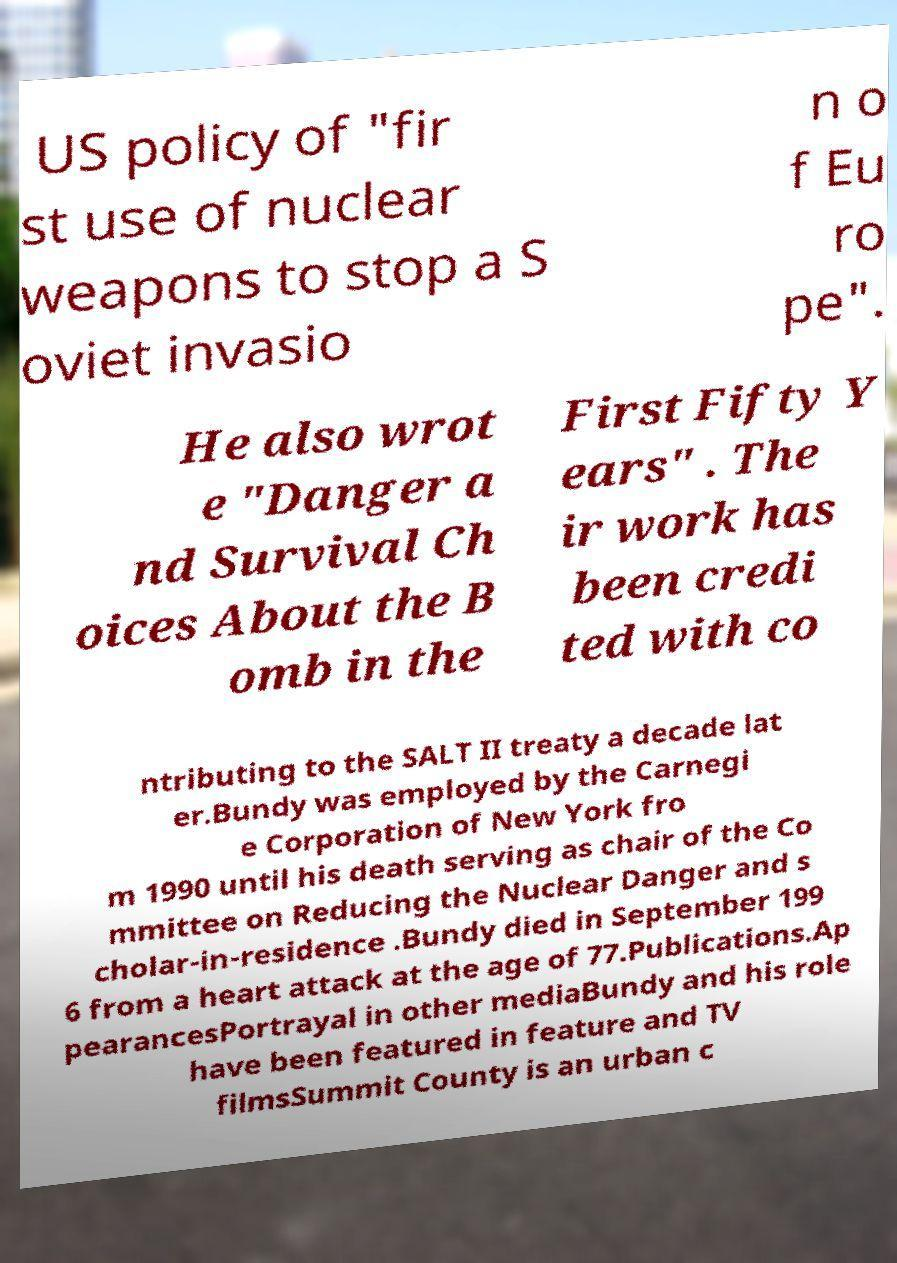There's text embedded in this image that I need extracted. Can you transcribe it verbatim? US policy of "fir st use of nuclear weapons to stop a S oviet invasio n o f Eu ro pe". He also wrot e "Danger a nd Survival Ch oices About the B omb in the First Fifty Y ears" . The ir work has been credi ted with co ntributing to the SALT II treaty a decade lat er.Bundy was employed by the Carnegi e Corporation of New York fro m 1990 until his death serving as chair of the Co mmittee on Reducing the Nuclear Danger and s cholar-in-residence .Bundy died in September 199 6 from a heart attack at the age of 77.Publications.Ap pearancesPortrayal in other mediaBundy and his role have been featured in feature and TV filmsSummit County is an urban c 